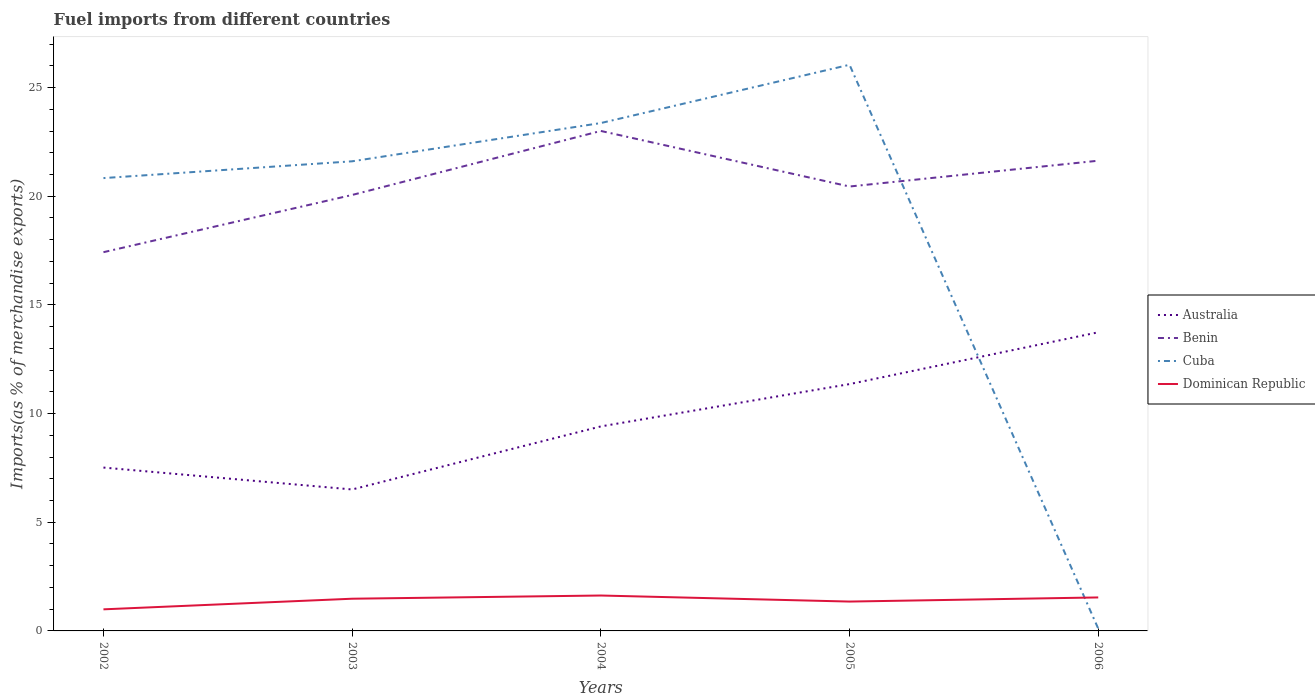How many different coloured lines are there?
Make the answer very short. 4. Across all years, what is the maximum percentage of imports to different countries in Australia?
Provide a succinct answer. 6.51. What is the total percentage of imports to different countries in Dominican Republic in the graph?
Your response must be concise. -0.49. What is the difference between the highest and the second highest percentage of imports to different countries in Australia?
Offer a very short reply. 7.23. Is the percentage of imports to different countries in Australia strictly greater than the percentage of imports to different countries in Dominican Republic over the years?
Make the answer very short. No. How many lines are there?
Keep it short and to the point. 4. How many years are there in the graph?
Offer a terse response. 5. What is the difference between two consecutive major ticks on the Y-axis?
Give a very brief answer. 5. Are the values on the major ticks of Y-axis written in scientific E-notation?
Provide a short and direct response. No. Does the graph contain any zero values?
Keep it short and to the point. No. What is the title of the graph?
Your answer should be compact. Fuel imports from different countries. What is the label or title of the X-axis?
Your answer should be compact. Years. What is the label or title of the Y-axis?
Make the answer very short. Imports(as % of merchandise exports). What is the Imports(as % of merchandise exports) of Australia in 2002?
Give a very brief answer. 7.52. What is the Imports(as % of merchandise exports) of Benin in 2002?
Offer a terse response. 17.43. What is the Imports(as % of merchandise exports) in Cuba in 2002?
Your answer should be very brief. 20.84. What is the Imports(as % of merchandise exports) of Dominican Republic in 2002?
Your answer should be compact. 0.99. What is the Imports(as % of merchandise exports) in Australia in 2003?
Your answer should be compact. 6.51. What is the Imports(as % of merchandise exports) in Benin in 2003?
Provide a succinct answer. 20.06. What is the Imports(as % of merchandise exports) in Cuba in 2003?
Your answer should be compact. 21.61. What is the Imports(as % of merchandise exports) of Dominican Republic in 2003?
Your answer should be very brief. 1.48. What is the Imports(as % of merchandise exports) of Australia in 2004?
Provide a short and direct response. 9.41. What is the Imports(as % of merchandise exports) in Benin in 2004?
Provide a short and direct response. 23.01. What is the Imports(as % of merchandise exports) in Cuba in 2004?
Keep it short and to the point. 23.37. What is the Imports(as % of merchandise exports) of Dominican Republic in 2004?
Ensure brevity in your answer.  1.63. What is the Imports(as % of merchandise exports) of Australia in 2005?
Provide a short and direct response. 11.36. What is the Imports(as % of merchandise exports) of Benin in 2005?
Offer a terse response. 20.45. What is the Imports(as % of merchandise exports) of Cuba in 2005?
Your response must be concise. 26.05. What is the Imports(as % of merchandise exports) of Dominican Republic in 2005?
Offer a very short reply. 1.35. What is the Imports(as % of merchandise exports) of Australia in 2006?
Offer a very short reply. 13.74. What is the Imports(as % of merchandise exports) of Benin in 2006?
Provide a succinct answer. 21.64. What is the Imports(as % of merchandise exports) in Cuba in 2006?
Provide a short and direct response. 0.11. What is the Imports(as % of merchandise exports) of Dominican Republic in 2006?
Offer a terse response. 1.54. Across all years, what is the maximum Imports(as % of merchandise exports) in Australia?
Provide a short and direct response. 13.74. Across all years, what is the maximum Imports(as % of merchandise exports) in Benin?
Your answer should be compact. 23.01. Across all years, what is the maximum Imports(as % of merchandise exports) of Cuba?
Provide a short and direct response. 26.05. Across all years, what is the maximum Imports(as % of merchandise exports) in Dominican Republic?
Your answer should be compact. 1.63. Across all years, what is the minimum Imports(as % of merchandise exports) in Australia?
Your response must be concise. 6.51. Across all years, what is the minimum Imports(as % of merchandise exports) in Benin?
Provide a short and direct response. 17.43. Across all years, what is the minimum Imports(as % of merchandise exports) in Cuba?
Make the answer very short. 0.11. Across all years, what is the minimum Imports(as % of merchandise exports) in Dominican Republic?
Offer a terse response. 0.99. What is the total Imports(as % of merchandise exports) of Australia in the graph?
Your answer should be very brief. 48.53. What is the total Imports(as % of merchandise exports) in Benin in the graph?
Your response must be concise. 102.58. What is the total Imports(as % of merchandise exports) in Cuba in the graph?
Offer a terse response. 91.97. What is the total Imports(as % of merchandise exports) of Dominican Republic in the graph?
Provide a short and direct response. 7. What is the difference between the Imports(as % of merchandise exports) in Australia in 2002 and that in 2003?
Offer a very short reply. 1.01. What is the difference between the Imports(as % of merchandise exports) of Benin in 2002 and that in 2003?
Your answer should be very brief. -2.63. What is the difference between the Imports(as % of merchandise exports) of Cuba in 2002 and that in 2003?
Provide a succinct answer. -0.77. What is the difference between the Imports(as % of merchandise exports) of Dominican Republic in 2002 and that in 2003?
Give a very brief answer. -0.49. What is the difference between the Imports(as % of merchandise exports) of Australia in 2002 and that in 2004?
Provide a succinct answer. -1.89. What is the difference between the Imports(as % of merchandise exports) of Benin in 2002 and that in 2004?
Your answer should be very brief. -5.58. What is the difference between the Imports(as % of merchandise exports) in Cuba in 2002 and that in 2004?
Ensure brevity in your answer.  -2.53. What is the difference between the Imports(as % of merchandise exports) of Dominican Republic in 2002 and that in 2004?
Keep it short and to the point. -0.64. What is the difference between the Imports(as % of merchandise exports) of Australia in 2002 and that in 2005?
Keep it short and to the point. -3.84. What is the difference between the Imports(as % of merchandise exports) of Benin in 2002 and that in 2005?
Provide a short and direct response. -3.02. What is the difference between the Imports(as % of merchandise exports) in Cuba in 2002 and that in 2005?
Ensure brevity in your answer.  -5.21. What is the difference between the Imports(as % of merchandise exports) of Dominican Republic in 2002 and that in 2005?
Keep it short and to the point. -0.36. What is the difference between the Imports(as % of merchandise exports) in Australia in 2002 and that in 2006?
Provide a succinct answer. -6.22. What is the difference between the Imports(as % of merchandise exports) in Benin in 2002 and that in 2006?
Offer a terse response. -4.21. What is the difference between the Imports(as % of merchandise exports) of Cuba in 2002 and that in 2006?
Offer a very short reply. 20.73. What is the difference between the Imports(as % of merchandise exports) in Dominican Republic in 2002 and that in 2006?
Keep it short and to the point. -0.55. What is the difference between the Imports(as % of merchandise exports) in Australia in 2003 and that in 2004?
Offer a very short reply. -2.9. What is the difference between the Imports(as % of merchandise exports) in Benin in 2003 and that in 2004?
Make the answer very short. -2.95. What is the difference between the Imports(as % of merchandise exports) in Cuba in 2003 and that in 2004?
Provide a short and direct response. -1.76. What is the difference between the Imports(as % of merchandise exports) in Dominican Republic in 2003 and that in 2004?
Your answer should be compact. -0.15. What is the difference between the Imports(as % of merchandise exports) in Australia in 2003 and that in 2005?
Offer a very short reply. -4.85. What is the difference between the Imports(as % of merchandise exports) of Benin in 2003 and that in 2005?
Make the answer very short. -0.39. What is the difference between the Imports(as % of merchandise exports) in Cuba in 2003 and that in 2005?
Your answer should be compact. -4.44. What is the difference between the Imports(as % of merchandise exports) in Dominican Republic in 2003 and that in 2005?
Keep it short and to the point. 0.13. What is the difference between the Imports(as % of merchandise exports) in Australia in 2003 and that in 2006?
Provide a succinct answer. -7.23. What is the difference between the Imports(as % of merchandise exports) of Benin in 2003 and that in 2006?
Keep it short and to the point. -1.58. What is the difference between the Imports(as % of merchandise exports) of Cuba in 2003 and that in 2006?
Keep it short and to the point. 21.5. What is the difference between the Imports(as % of merchandise exports) in Dominican Republic in 2003 and that in 2006?
Your answer should be very brief. -0.06. What is the difference between the Imports(as % of merchandise exports) in Australia in 2004 and that in 2005?
Offer a very short reply. -1.95. What is the difference between the Imports(as % of merchandise exports) in Benin in 2004 and that in 2005?
Make the answer very short. 2.56. What is the difference between the Imports(as % of merchandise exports) of Cuba in 2004 and that in 2005?
Offer a terse response. -2.68. What is the difference between the Imports(as % of merchandise exports) in Dominican Republic in 2004 and that in 2005?
Your answer should be compact. 0.28. What is the difference between the Imports(as % of merchandise exports) in Australia in 2004 and that in 2006?
Keep it short and to the point. -4.33. What is the difference between the Imports(as % of merchandise exports) of Benin in 2004 and that in 2006?
Ensure brevity in your answer.  1.37. What is the difference between the Imports(as % of merchandise exports) of Cuba in 2004 and that in 2006?
Your answer should be compact. 23.26. What is the difference between the Imports(as % of merchandise exports) of Dominican Republic in 2004 and that in 2006?
Offer a terse response. 0.09. What is the difference between the Imports(as % of merchandise exports) of Australia in 2005 and that in 2006?
Your answer should be very brief. -2.38. What is the difference between the Imports(as % of merchandise exports) in Benin in 2005 and that in 2006?
Your answer should be very brief. -1.19. What is the difference between the Imports(as % of merchandise exports) in Cuba in 2005 and that in 2006?
Provide a succinct answer. 25.94. What is the difference between the Imports(as % of merchandise exports) in Dominican Republic in 2005 and that in 2006?
Your answer should be compact. -0.19. What is the difference between the Imports(as % of merchandise exports) in Australia in 2002 and the Imports(as % of merchandise exports) in Benin in 2003?
Your answer should be compact. -12.54. What is the difference between the Imports(as % of merchandise exports) in Australia in 2002 and the Imports(as % of merchandise exports) in Cuba in 2003?
Offer a terse response. -14.09. What is the difference between the Imports(as % of merchandise exports) of Australia in 2002 and the Imports(as % of merchandise exports) of Dominican Republic in 2003?
Offer a very short reply. 6.03. What is the difference between the Imports(as % of merchandise exports) of Benin in 2002 and the Imports(as % of merchandise exports) of Cuba in 2003?
Your answer should be very brief. -4.18. What is the difference between the Imports(as % of merchandise exports) in Benin in 2002 and the Imports(as % of merchandise exports) in Dominican Republic in 2003?
Your answer should be compact. 15.95. What is the difference between the Imports(as % of merchandise exports) in Cuba in 2002 and the Imports(as % of merchandise exports) in Dominican Republic in 2003?
Offer a very short reply. 19.35. What is the difference between the Imports(as % of merchandise exports) of Australia in 2002 and the Imports(as % of merchandise exports) of Benin in 2004?
Ensure brevity in your answer.  -15.49. What is the difference between the Imports(as % of merchandise exports) of Australia in 2002 and the Imports(as % of merchandise exports) of Cuba in 2004?
Your answer should be very brief. -15.85. What is the difference between the Imports(as % of merchandise exports) in Australia in 2002 and the Imports(as % of merchandise exports) in Dominican Republic in 2004?
Provide a succinct answer. 5.89. What is the difference between the Imports(as % of merchandise exports) of Benin in 2002 and the Imports(as % of merchandise exports) of Cuba in 2004?
Offer a terse response. -5.94. What is the difference between the Imports(as % of merchandise exports) of Benin in 2002 and the Imports(as % of merchandise exports) of Dominican Republic in 2004?
Provide a succinct answer. 15.8. What is the difference between the Imports(as % of merchandise exports) of Cuba in 2002 and the Imports(as % of merchandise exports) of Dominican Republic in 2004?
Provide a short and direct response. 19.21. What is the difference between the Imports(as % of merchandise exports) of Australia in 2002 and the Imports(as % of merchandise exports) of Benin in 2005?
Keep it short and to the point. -12.93. What is the difference between the Imports(as % of merchandise exports) of Australia in 2002 and the Imports(as % of merchandise exports) of Cuba in 2005?
Your answer should be very brief. -18.53. What is the difference between the Imports(as % of merchandise exports) of Australia in 2002 and the Imports(as % of merchandise exports) of Dominican Republic in 2005?
Make the answer very short. 6.17. What is the difference between the Imports(as % of merchandise exports) of Benin in 2002 and the Imports(as % of merchandise exports) of Cuba in 2005?
Provide a short and direct response. -8.62. What is the difference between the Imports(as % of merchandise exports) of Benin in 2002 and the Imports(as % of merchandise exports) of Dominican Republic in 2005?
Provide a short and direct response. 16.08. What is the difference between the Imports(as % of merchandise exports) of Cuba in 2002 and the Imports(as % of merchandise exports) of Dominican Republic in 2005?
Offer a terse response. 19.48. What is the difference between the Imports(as % of merchandise exports) in Australia in 2002 and the Imports(as % of merchandise exports) in Benin in 2006?
Offer a very short reply. -14.12. What is the difference between the Imports(as % of merchandise exports) in Australia in 2002 and the Imports(as % of merchandise exports) in Cuba in 2006?
Offer a terse response. 7.41. What is the difference between the Imports(as % of merchandise exports) of Australia in 2002 and the Imports(as % of merchandise exports) of Dominican Republic in 2006?
Ensure brevity in your answer.  5.98. What is the difference between the Imports(as % of merchandise exports) in Benin in 2002 and the Imports(as % of merchandise exports) in Cuba in 2006?
Your answer should be very brief. 17.32. What is the difference between the Imports(as % of merchandise exports) in Benin in 2002 and the Imports(as % of merchandise exports) in Dominican Republic in 2006?
Ensure brevity in your answer.  15.89. What is the difference between the Imports(as % of merchandise exports) in Cuba in 2002 and the Imports(as % of merchandise exports) in Dominican Republic in 2006?
Provide a succinct answer. 19.3. What is the difference between the Imports(as % of merchandise exports) in Australia in 2003 and the Imports(as % of merchandise exports) in Benin in 2004?
Ensure brevity in your answer.  -16.5. What is the difference between the Imports(as % of merchandise exports) in Australia in 2003 and the Imports(as % of merchandise exports) in Cuba in 2004?
Offer a terse response. -16.86. What is the difference between the Imports(as % of merchandise exports) in Australia in 2003 and the Imports(as % of merchandise exports) in Dominican Republic in 2004?
Your response must be concise. 4.88. What is the difference between the Imports(as % of merchandise exports) in Benin in 2003 and the Imports(as % of merchandise exports) in Cuba in 2004?
Offer a terse response. -3.31. What is the difference between the Imports(as % of merchandise exports) of Benin in 2003 and the Imports(as % of merchandise exports) of Dominican Republic in 2004?
Provide a succinct answer. 18.43. What is the difference between the Imports(as % of merchandise exports) of Cuba in 2003 and the Imports(as % of merchandise exports) of Dominican Republic in 2004?
Your response must be concise. 19.98. What is the difference between the Imports(as % of merchandise exports) of Australia in 2003 and the Imports(as % of merchandise exports) of Benin in 2005?
Provide a succinct answer. -13.94. What is the difference between the Imports(as % of merchandise exports) of Australia in 2003 and the Imports(as % of merchandise exports) of Cuba in 2005?
Ensure brevity in your answer.  -19.54. What is the difference between the Imports(as % of merchandise exports) of Australia in 2003 and the Imports(as % of merchandise exports) of Dominican Republic in 2005?
Give a very brief answer. 5.16. What is the difference between the Imports(as % of merchandise exports) of Benin in 2003 and the Imports(as % of merchandise exports) of Cuba in 2005?
Provide a succinct answer. -5.99. What is the difference between the Imports(as % of merchandise exports) in Benin in 2003 and the Imports(as % of merchandise exports) in Dominican Republic in 2005?
Make the answer very short. 18.71. What is the difference between the Imports(as % of merchandise exports) of Cuba in 2003 and the Imports(as % of merchandise exports) of Dominican Republic in 2005?
Give a very brief answer. 20.26. What is the difference between the Imports(as % of merchandise exports) of Australia in 2003 and the Imports(as % of merchandise exports) of Benin in 2006?
Your answer should be very brief. -15.13. What is the difference between the Imports(as % of merchandise exports) in Australia in 2003 and the Imports(as % of merchandise exports) in Cuba in 2006?
Ensure brevity in your answer.  6.4. What is the difference between the Imports(as % of merchandise exports) of Australia in 2003 and the Imports(as % of merchandise exports) of Dominican Republic in 2006?
Give a very brief answer. 4.97. What is the difference between the Imports(as % of merchandise exports) of Benin in 2003 and the Imports(as % of merchandise exports) of Cuba in 2006?
Give a very brief answer. 19.95. What is the difference between the Imports(as % of merchandise exports) in Benin in 2003 and the Imports(as % of merchandise exports) in Dominican Republic in 2006?
Your response must be concise. 18.52. What is the difference between the Imports(as % of merchandise exports) of Cuba in 2003 and the Imports(as % of merchandise exports) of Dominican Republic in 2006?
Your answer should be compact. 20.07. What is the difference between the Imports(as % of merchandise exports) of Australia in 2004 and the Imports(as % of merchandise exports) of Benin in 2005?
Offer a terse response. -11.04. What is the difference between the Imports(as % of merchandise exports) in Australia in 2004 and the Imports(as % of merchandise exports) in Cuba in 2005?
Your response must be concise. -16.64. What is the difference between the Imports(as % of merchandise exports) in Australia in 2004 and the Imports(as % of merchandise exports) in Dominican Republic in 2005?
Provide a short and direct response. 8.06. What is the difference between the Imports(as % of merchandise exports) of Benin in 2004 and the Imports(as % of merchandise exports) of Cuba in 2005?
Your answer should be very brief. -3.05. What is the difference between the Imports(as % of merchandise exports) in Benin in 2004 and the Imports(as % of merchandise exports) in Dominican Republic in 2005?
Offer a terse response. 21.65. What is the difference between the Imports(as % of merchandise exports) of Cuba in 2004 and the Imports(as % of merchandise exports) of Dominican Republic in 2005?
Offer a terse response. 22.02. What is the difference between the Imports(as % of merchandise exports) of Australia in 2004 and the Imports(as % of merchandise exports) of Benin in 2006?
Keep it short and to the point. -12.23. What is the difference between the Imports(as % of merchandise exports) of Australia in 2004 and the Imports(as % of merchandise exports) of Cuba in 2006?
Keep it short and to the point. 9.3. What is the difference between the Imports(as % of merchandise exports) of Australia in 2004 and the Imports(as % of merchandise exports) of Dominican Republic in 2006?
Your response must be concise. 7.87. What is the difference between the Imports(as % of merchandise exports) in Benin in 2004 and the Imports(as % of merchandise exports) in Cuba in 2006?
Make the answer very short. 22.9. What is the difference between the Imports(as % of merchandise exports) of Benin in 2004 and the Imports(as % of merchandise exports) of Dominican Republic in 2006?
Your answer should be compact. 21.46. What is the difference between the Imports(as % of merchandise exports) in Cuba in 2004 and the Imports(as % of merchandise exports) in Dominican Republic in 2006?
Ensure brevity in your answer.  21.83. What is the difference between the Imports(as % of merchandise exports) in Australia in 2005 and the Imports(as % of merchandise exports) in Benin in 2006?
Ensure brevity in your answer.  -10.28. What is the difference between the Imports(as % of merchandise exports) of Australia in 2005 and the Imports(as % of merchandise exports) of Cuba in 2006?
Make the answer very short. 11.25. What is the difference between the Imports(as % of merchandise exports) in Australia in 2005 and the Imports(as % of merchandise exports) in Dominican Republic in 2006?
Offer a terse response. 9.82. What is the difference between the Imports(as % of merchandise exports) in Benin in 2005 and the Imports(as % of merchandise exports) in Cuba in 2006?
Give a very brief answer. 20.34. What is the difference between the Imports(as % of merchandise exports) of Benin in 2005 and the Imports(as % of merchandise exports) of Dominican Republic in 2006?
Give a very brief answer. 18.91. What is the difference between the Imports(as % of merchandise exports) of Cuba in 2005 and the Imports(as % of merchandise exports) of Dominican Republic in 2006?
Ensure brevity in your answer.  24.51. What is the average Imports(as % of merchandise exports) in Australia per year?
Make the answer very short. 9.71. What is the average Imports(as % of merchandise exports) in Benin per year?
Make the answer very short. 20.52. What is the average Imports(as % of merchandise exports) of Cuba per year?
Make the answer very short. 18.39. What is the average Imports(as % of merchandise exports) of Dominican Republic per year?
Your answer should be very brief. 1.4. In the year 2002, what is the difference between the Imports(as % of merchandise exports) of Australia and Imports(as % of merchandise exports) of Benin?
Your answer should be compact. -9.91. In the year 2002, what is the difference between the Imports(as % of merchandise exports) in Australia and Imports(as % of merchandise exports) in Cuba?
Offer a very short reply. -13.32. In the year 2002, what is the difference between the Imports(as % of merchandise exports) in Australia and Imports(as % of merchandise exports) in Dominican Republic?
Offer a terse response. 6.52. In the year 2002, what is the difference between the Imports(as % of merchandise exports) in Benin and Imports(as % of merchandise exports) in Cuba?
Your answer should be compact. -3.41. In the year 2002, what is the difference between the Imports(as % of merchandise exports) in Benin and Imports(as % of merchandise exports) in Dominican Republic?
Ensure brevity in your answer.  16.43. In the year 2002, what is the difference between the Imports(as % of merchandise exports) of Cuba and Imports(as % of merchandise exports) of Dominican Republic?
Your answer should be compact. 19.84. In the year 2003, what is the difference between the Imports(as % of merchandise exports) of Australia and Imports(as % of merchandise exports) of Benin?
Give a very brief answer. -13.55. In the year 2003, what is the difference between the Imports(as % of merchandise exports) of Australia and Imports(as % of merchandise exports) of Cuba?
Your answer should be very brief. -15.1. In the year 2003, what is the difference between the Imports(as % of merchandise exports) of Australia and Imports(as % of merchandise exports) of Dominican Republic?
Your answer should be very brief. 5.03. In the year 2003, what is the difference between the Imports(as % of merchandise exports) in Benin and Imports(as % of merchandise exports) in Cuba?
Make the answer very short. -1.55. In the year 2003, what is the difference between the Imports(as % of merchandise exports) in Benin and Imports(as % of merchandise exports) in Dominican Republic?
Give a very brief answer. 18.58. In the year 2003, what is the difference between the Imports(as % of merchandise exports) in Cuba and Imports(as % of merchandise exports) in Dominican Republic?
Offer a very short reply. 20.13. In the year 2004, what is the difference between the Imports(as % of merchandise exports) in Australia and Imports(as % of merchandise exports) in Benin?
Offer a terse response. -13.59. In the year 2004, what is the difference between the Imports(as % of merchandise exports) in Australia and Imports(as % of merchandise exports) in Cuba?
Provide a succinct answer. -13.96. In the year 2004, what is the difference between the Imports(as % of merchandise exports) of Australia and Imports(as % of merchandise exports) of Dominican Republic?
Your response must be concise. 7.78. In the year 2004, what is the difference between the Imports(as % of merchandise exports) of Benin and Imports(as % of merchandise exports) of Cuba?
Keep it short and to the point. -0.36. In the year 2004, what is the difference between the Imports(as % of merchandise exports) in Benin and Imports(as % of merchandise exports) in Dominican Republic?
Provide a short and direct response. 21.38. In the year 2004, what is the difference between the Imports(as % of merchandise exports) in Cuba and Imports(as % of merchandise exports) in Dominican Republic?
Offer a terse response. 21.74. In the year 2005, what is the difference between the Imports(as % of merchandise exports) of Australia and Imports(as % of merchandise exports) of Benin?
Your answer should be compact. -9.09. In the year 2005, what is the difference between the Imports(as % of merchandise exports) of Australia and Imports(as % of merchandise exports) of Cuba?
Provide a short and direct response. -14.69. In the year 2005, what is the difference between the Imports(as % of merchandise exports) of Australia and Imports(as % of merchandise exports) of Dominican Republic?
Your answer should be very brief. 10.01. In the year 2005, what is the difference between the Imports(as % of merchandise exports) in Benin and Imports(as % of merchandise exports) in Cuba?
Make the answer very short. -5.6. In the year 2005, what is the difference between the Imports(as % of merchandise exports) of Benin and Imports(as % of merchandise exports) of Dominican Republic?
Ensure brevity in your answer.  19.1. In the year 2005, what is the difference between the Imports(as % of merchandise exports) of Cuba and Imports(as % of merchandise exports) of Dominican Republic?
Your answer should be very brief. 24.7. In the year 2006, what is the difference between the Imports(as % of merchandise exports) of Australia and Imports(as % of merchandise exports) of Benin?
Offer a terse response. -7.9. In the year 2006, what is the difference between the Imports(as % of merchandise exports) in Australia and Imports(as % of merchandise exports) in Cuba?
Offer a very short reply. 13.63. In the year 2006, what is the difference between the Imports(as % of merchandise exports) of Australia and Imports(as % of merchandise exports) of Dominican Republic?
Provide a short and direct response. 12.2. In the year 2006, what is the difference between the Imports(as % of merchandise exports) of Benin and Imports(as % of merchandise exports) of Cuba?
Your answer should be very brief. 21.53. In the year 2006, what is the difference between the Imports(as % of merchandise exports) of Benin and Imports(as % of merchandise exports) of Dominican Republic?
Make the answer very short. 20.1. In the year 2006, what is the difference between the Imports(as % of merchandise exports) in Cuba and Imports(as % of merchandise exports) in Dominican Republic?
Provide a succinct answer. -1.43. What is the ratio of the Imports(as % of merchandise exports) in Australia in 2002 to that in 2003?
Your answer should be very brief. 1.15. What is the ratio of the Imports(as % of merchandise exports) in Benin in 2002 to that in 2003?
Offer a very short reply. 0.87. What is the ratio of the Imports(as % of merchandise exports) in Cuba in 2002 to that in 2003?
Offer a very short reply. 0.96. What is the ratio of the Imports(as % of merchandise exports) in Dominican Republic in 2002 to that in 2003?
Your response must be concise. 0.67. What is the ratio of the Imports(as % of merchandise exports) of Australia in 2002 to that in 2004?
Offer a very short reply. 0.8. What is the ratio of the Imports(as % of merchandise exports) of Benin in 2002 to that in 2004?
Provide a succinct answer. 0.76. What is the ratio of the Imports(as % of merchandise exports) in Cuba in 2002 to that in 2004?
Offer a terse response. 0.89. What is the ratio of the Imports(as % of merchandise exports) in Dominican Republic in 2002 to that in 2004?
Ensure brevity in your answer.  0.61. What is the ratio of the Imports(as % of merchandise exports) in Australia in 2002 to that in 2005?
Offer a terse response. 0.66. What is the ratio of the Imports(as % of merchandise exports) in Benin in 2002 to that in 2005?
Provide a succinct answer. 0.85. What is the ratio of the Imports(as % of merchandise exports) of Cuba in 2002 to that in 2005?
Provide a short and direct response. 0.8. What is the ratio of the Imports(as % of merchandise exports) in Dominican Republic in 2002 to that in 2005?
Your response must be concise. 0.74. What is the ratio of the Imports(as % of merchandise exports) of Australia in 2002 to that in 2006?
Your answer should be very brief. 0.55. What is the ratio of the Imports(as % of merchandise exports) in Benin in 2002 to that in 2006?
Ensure brevity in your answer.  0.81. What is the ratio of the Imports(as % of merchandise exports) in Cuba in 2002 to that in 2006?
Make the answer very short. 195.38. What is the ratio of the Imports(as % of merchandise exports) in Dominican Republic in 2002 to that in 2006?
Your answer should be compact. 0.64. What is the ratio of the Imports(as % of merchandise exports) of Australia in 2003 to that in 2004?
Ensure brevity in your answer.  0.69. What is the ratio of the Imports(as % of merchandise exports) of Benin in 2003 to that in 2004?
Make the answer very short. 0.87. What is the ratio of the Imports(as % of merchandise exports) of Cuba in 2003 to that in 2004?
Your answer should be very brief. 0.92. What is the ratio of the Imports(as % of merchandise exports) of Dominican Republic in 2003 to that in 2004?
Offer a terse response. 0.91. What is the ratio of the Imports(as % of merchandise exports) of Australia in 2003 to that in 2005?
Provide a succinct answer. 0.57. What is the ratio of the Imports(as % of merchandise exports) of Benin in 2003 to that in 2005?
Offer a terse response. 0.98. What is the ratio of the Imports(as % of merchandise exports) in Cuba in 2003 to that in 2005?
Your answer should be compact. 0.83. What is the ratio of the Imports(as % of merchandise exports) in Dominican Republic in 2003 to that in 2005?
Provide a short and direct response. 1.1. What is the ratio of the Imports(as % of merchandise exports) in Australia in 2003 to that in 2006?
Your answer should be compact. 0.47. What is the ratio of the Imports(as % of merchandise exports) in Benin in 2003 to that in 2006?
Ensure brevity in your answer.  0.93. What is the ratio of the Imports(as % of merchandise exports) of Cuba in 2003 to that in 2006?
Provide a short and direct response. 202.63. What is the ratio of the Imports(as % of merchandise exports) in Dominican Republic in 2003 to that in 2006?
Offer a terse response. 0.96. What is the ratio of the Imports(as % of merchandise exports) in Australia in 2004 to that in 2005?
Keep it short and to the point. 0.83. What is the ratio of the Imports(as % of merchandise exports) of Benin in 2004 to that in 2005?
Provide a succinct answer. 1.12. What is the ratio of the Imports(as % of merchandise exports) in Cuba in 2004 to that in 2005?
Keep it short and to the point. 0.9. What is the ratio of the Imports(as % of merchandise exports) of Dominican Republic in 2004 to that in 2005?
Your answer should be very brief. 1.21. What is the ratio of the Imports(as % of merchandise exports) of Australia in 2004 to that in 2006?
Provide a short and direct response. 0.68. What is the ratio of the Imports(as % of merchandise exports) in Benin in 2004 to that in 2006?
Provide a short and direct response. 1.06. What is the ratio of the Imports(as % of merchandise exports) of Cuba in 2004 to that in 2006?
Make the answer very short. 219.14. What is the ratio of the Imports(as % of merchandise exports) in Dominican Republic in 2004 to that in 2006?
Give a very brief answer. 1.06. What is the ratio of the Imports(as % of merchandise exports) in Australia in 2005 to that in 2006?
Offer a terse response. 0.83. What is the ratio of the Imports(as % of merchandise exports) of Benin in 2005 to that in 2006?
Keep it short and to the point. 0.95. What is the ratio of the Imports(as % of merchandise exports) in Cuba in 2005 to that in 2006?
Provide a short and direct response. 244.28. What is the ratio of the Imports(as % of merchandise exports) of Dominican Republic in 2005 to that in 2006?
Your response must be concise. 0.88. What is the difference between the highest and the second highest Imports(as % of merchandise exports) in Australia?
Your answer should be very brief. 2.38. What is the difference between the highest and the second highest Imports(as % of merchandise exports) in Benin?
Provide a short and direct response. 1.37. What is the difference between the highest and the second highest Imports(as % of merchandise exports) of Cuba?
Provide a short and direct response. 2.68. What is the difference between the highest and the second highest Imports(as % of merchandise exports) in Dominican Republic?
Offer a very short reply. 0.09. What is the difference between the highest and the lowest Imports(as % of merchandise exports) in Australia?
Ensure brevity in your answer.  7.23. What is the difference between the highest and the lowest Imports(as % of merchandise exports) of Benin?
Make the answer very short. 5.58. What is the difference between the highest and the lowest Imports(as % of merchandise exports) of Cuba?
Your response must be concise. 25.94. What is the difference between the highest and the lowest Imports(as % of merchandise exports) of Dominican Republic?
Provide a succinct answer. 0.64. 